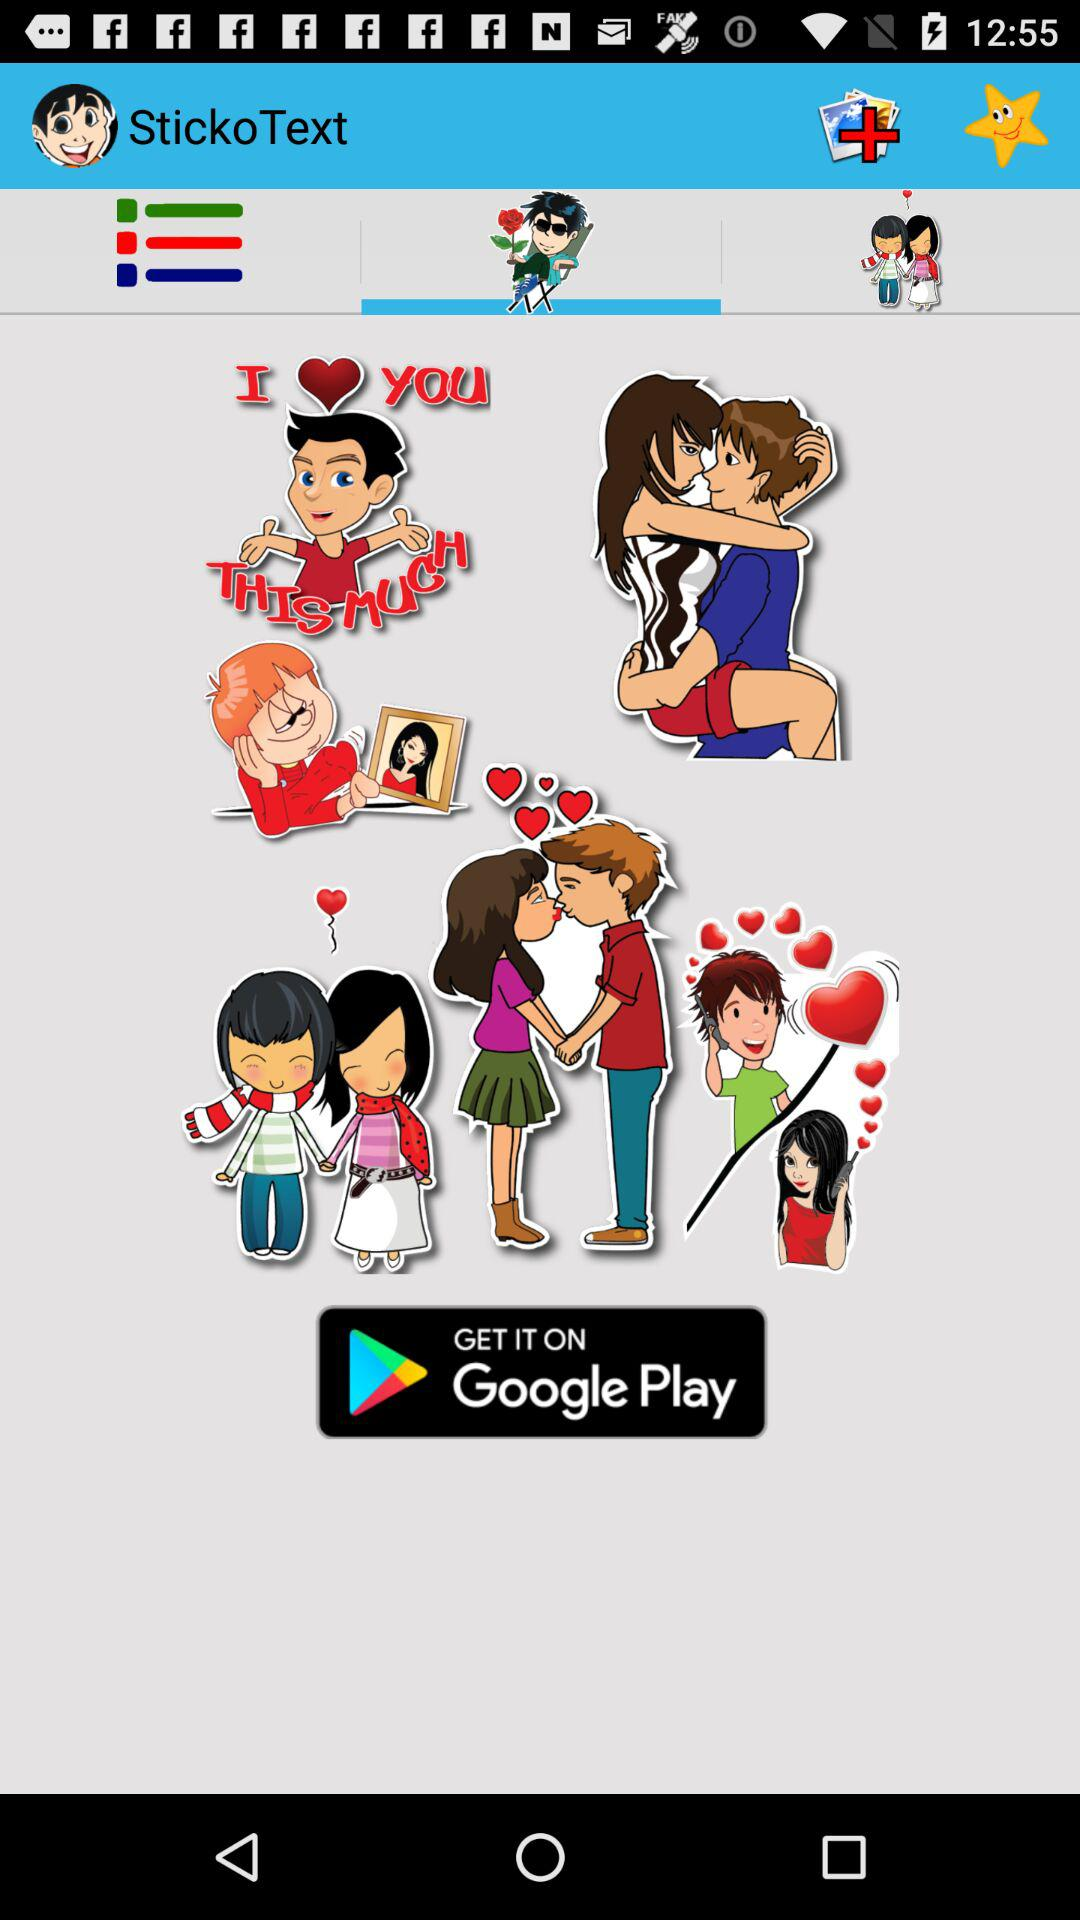What's the application name where the stickers can be gotten? The application name is "StickoText". 